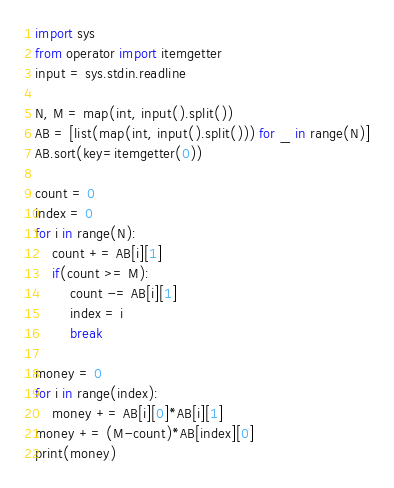Convert code to text. <code><loc_0><loc_0><loc_500><loc_500><_Python_>import sys
from operator import itemgetter
input = sys.stdin.readline

N, M = map(int, input().split())
AB = [list(map(int, input().split())) for _ in range(N)]
AB.sort(key=itemgetter(0))

count = 0
index = 0
for i in range(N):
    count += AB[i][1]
    if(count >= M):
        count -= AB[i][1]
        index = i
        break

money = 0
for i in range(index):
    money += AB[i][0]*AB[i][1]
money += (M-count)*AB[index][0]
print(money)</code> 